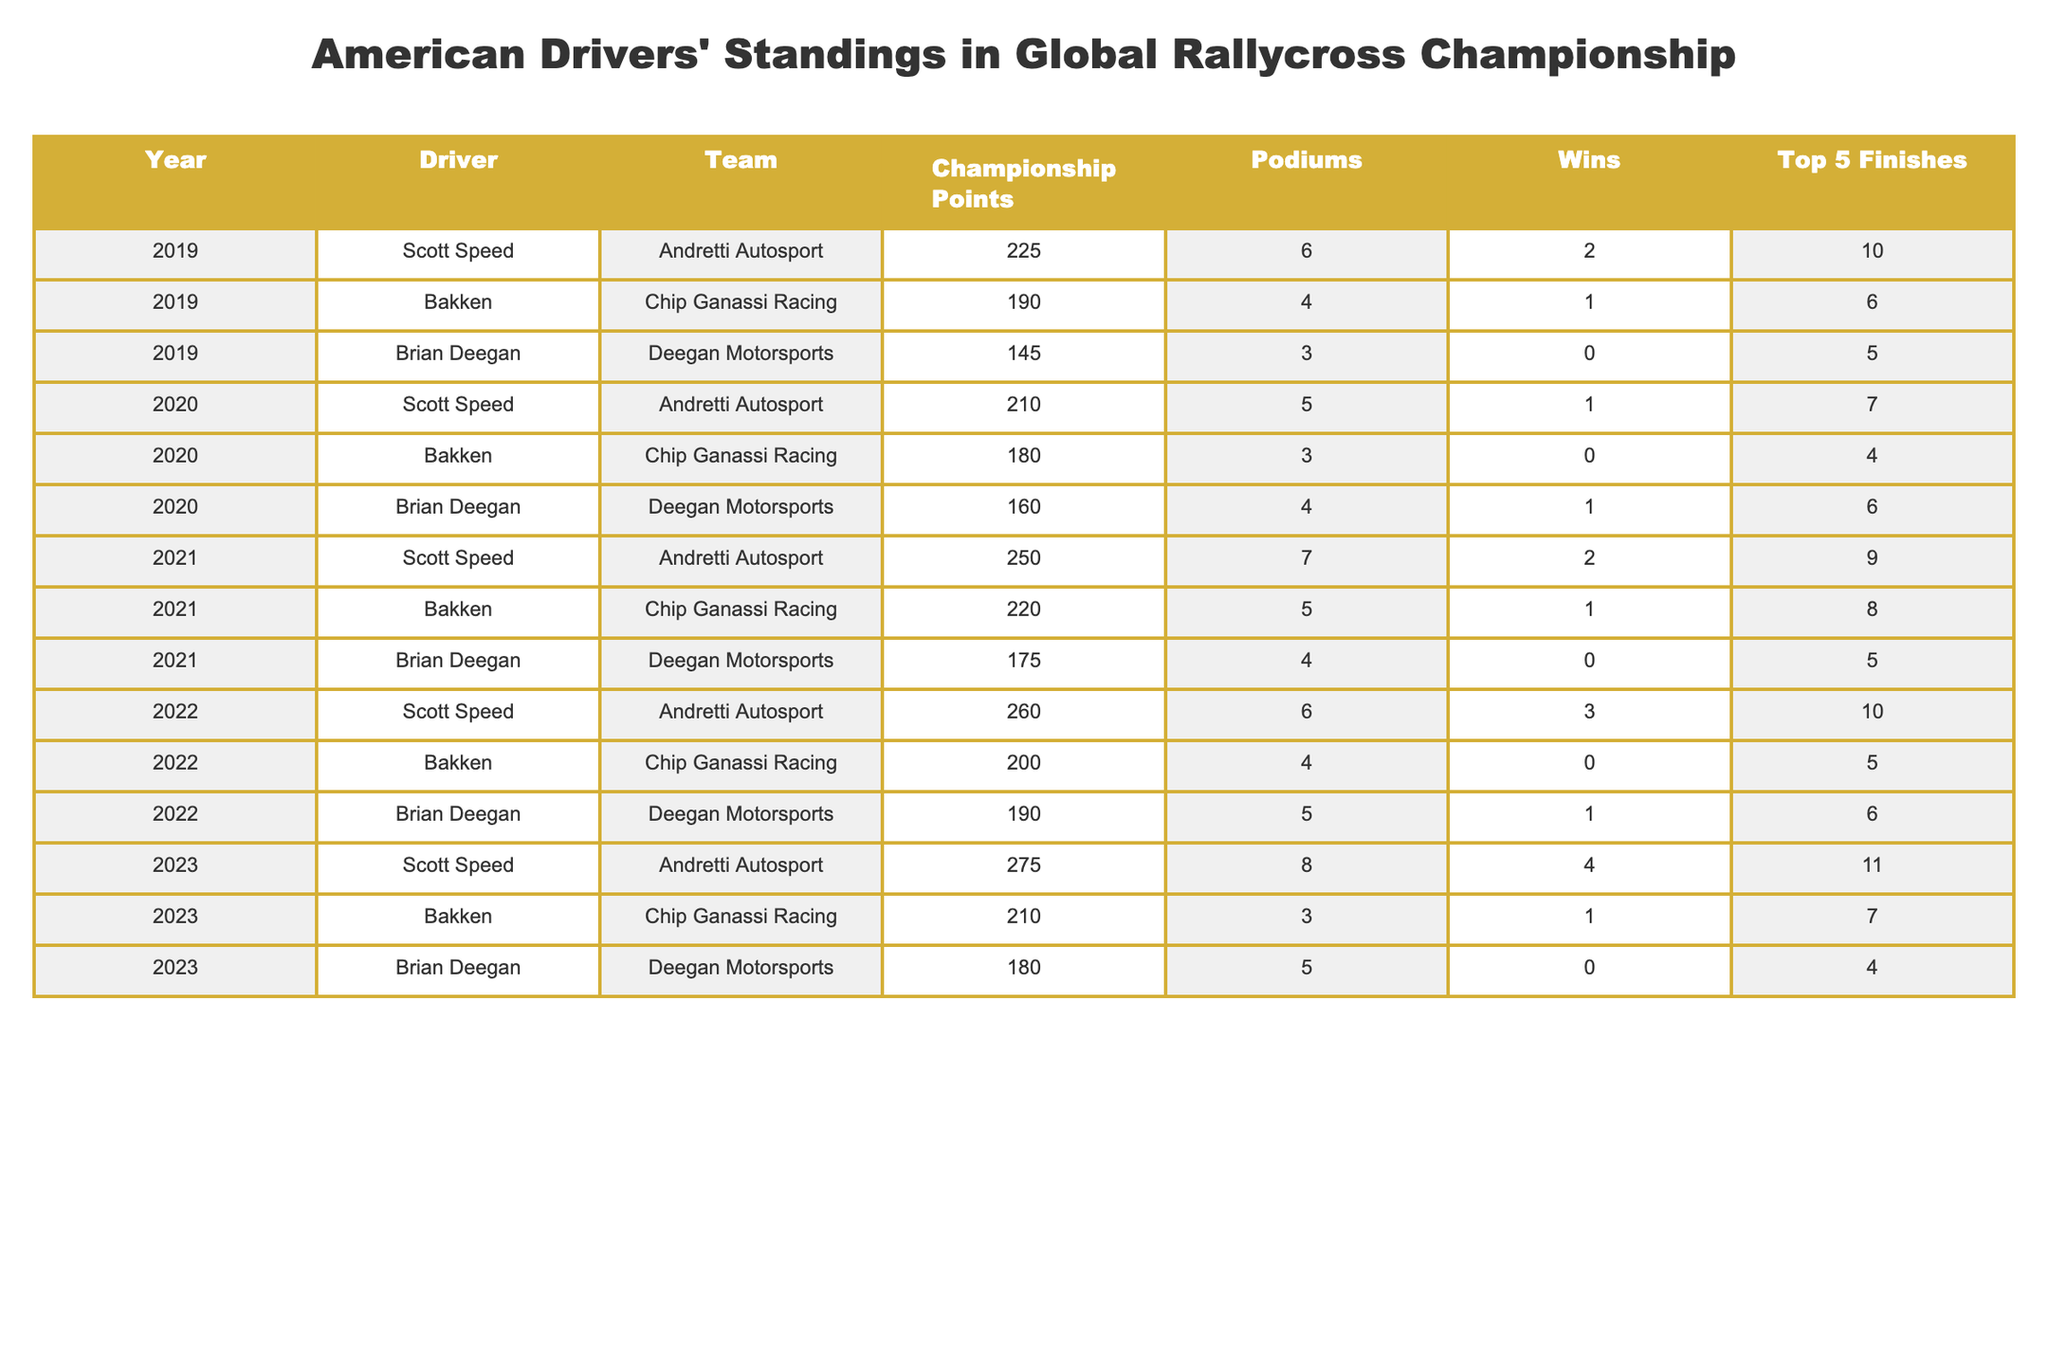What was Scott Speed's total Championship Points over the five years? He scored 225 in 2019, 210 in 2020, 250 in 2021, 260 in 2022, and 275 in 2023. Adding these together gives 225 + 210 + 250 + 260 + 275 = 1220.
Answer: 1220 Which driver had the most wins in 2022? The wins in 2022 are 3 for Scott Speed, 0 for Bakken, and 1 for Brian Deegan. Comparing these, Scott Speed had the most wins with 3.
Answer: Scott Speed What is the average number of podiums for American drivers over the last five years? The total podiums are 6 (2019) + 4 + 3 + 5 + 7 (2020) + 4 + 4 + 5 + 6 (2021) + 4 + 5 + 5 + 6 (2022) + 8 + 3 + 5 (2023) = 50. There are 15 data points, so average is 50 / 15 = 3.33.
Answer: 3.33 Did Bakken have at least one win every year from 2019 to 2023? Bakken had wins of 1 in 2019, 0 in 2020, 1 in 2021, 0 in 2022, and 1 in 2023. Since he had two years without a win, the statement is false.
Answer: No How many Top 5 finishes did Brian Deegan achieve in total? The total Top 5 finishes are 5 (2019) + 6 (2020) + 5 (2021) + 6 (2022) + 4 (2023) = 26.
Answer: 26 Which driver improved their Championship Points every year from 2019 to 2023? Looking at the points, Scott Speed had points of 225 (2019), 210 (2020), 250 (2021), 260 (2022), and 275 (2023). He improved in all years. Bakken and Deegan did not improve every year based on their point data. Thus, the answer is Scott Speed.
Answer: Scott Speed What was the difference in championship points between Scott Speed and Brian Deegan in 2021? Scott Speed had 250 points and Brian Deegan had 175 points in 2021. The difference is 250 - 175 = 75 points.
Answer: 75 Which driver had the highest number of podium finishes in 2023? In 2023, Scott Speed had 8 podiums, Bakken had 3, and Brian Deegan had 5. Therefore, Scott Speed had the highest.
Answer: Scott Speed What trend can be deduced from Scott Speed's performance over the years? Scott Speed's Championship Points increased every year (225, 210, 250, 260, 275), showing consistent improvement and performance in the Championship.
Answer: Consistent improvement 